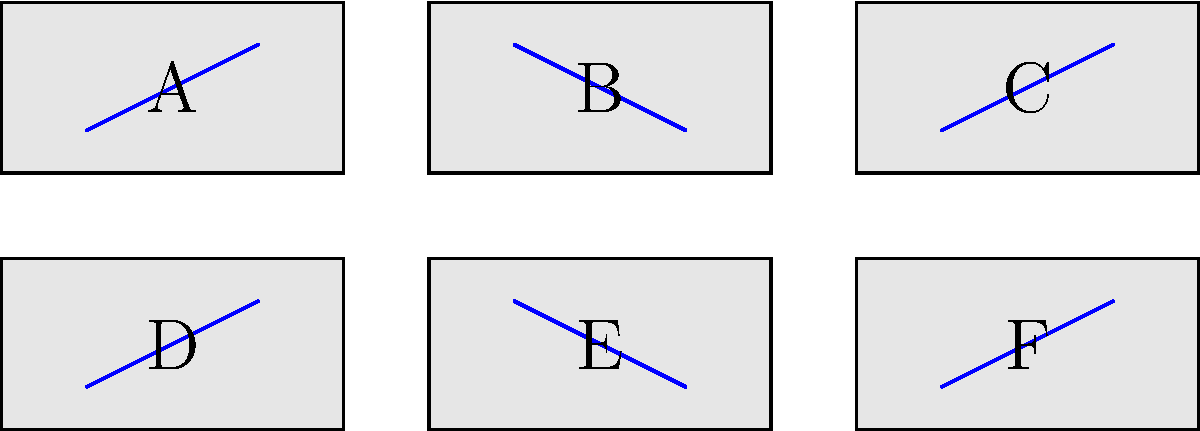Arrange the sheet music fragments to form a complete musical score for a composition by Clara Schumann. The correct order should create a continuous melodic line. Which sequence of letters represents the correct arrangement? To solve this puzzle, we need to analyze the musical symbols on each fragment and determine how they connect to form a continuous melodic line. Let's follow these steps:

1. Observe that each fragment contains a blue line representing a portion of the melody.

2. Fragment A starts with an ascending line, so it's likely the beginning of the piece.

3. Fragment C ends with an ascending line, so it's probably the end of the piece.

4. The remaining fragments should connect the beginning and end smoothly.

5. Looking at the fragments:
   - B continues the ascending line from A
   - E descends from B's endpoint
   - D continues the descending line from E
   - F ascends from D's endpoint, connecting to C

6. Therefore, the correct sequence to create a continuous melodic line is:
   A → B → E → D → F → C

This arrangement would create a musical phrase that rises, falls, and then rises again, which is a common structure in classical compositions, including those by Clara Schumann.
Answer: ABEDF C 